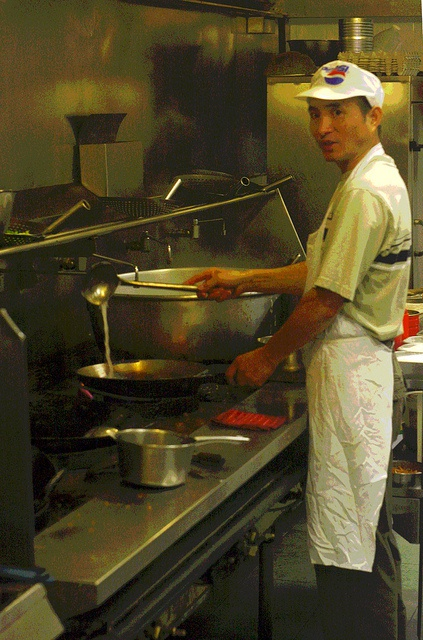Describe the objects in this image and their specific colors. I can see people in maroon, tan, olive, and black tones, oven in maroon, black, and darkgreen tones, chair in maroon, black, and darkgreen tones, knife in maroon, black, and darkgreen tones, and spoon in maroon, black, and olive tones in this image. 